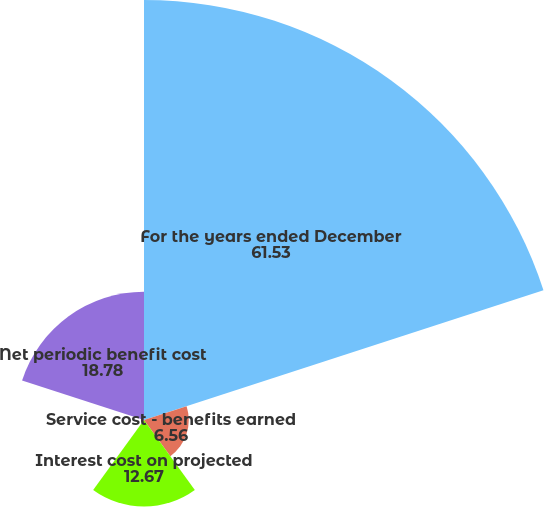Convert chart. <chart><loc_0><loc_0><loc_500><loc_500><pie_chart><fcel>For the years ended December<fcel>Service cost - benefits earned<fcel>Interest cost on projected<fcel>Recognized actuarial loss<fcel>Net periodic benefit cost<nl><fcel>61.53%<fcel>6.56%<fcel>12.67%<fcel>0.46%<fcel>18.78%<nl></chart> 